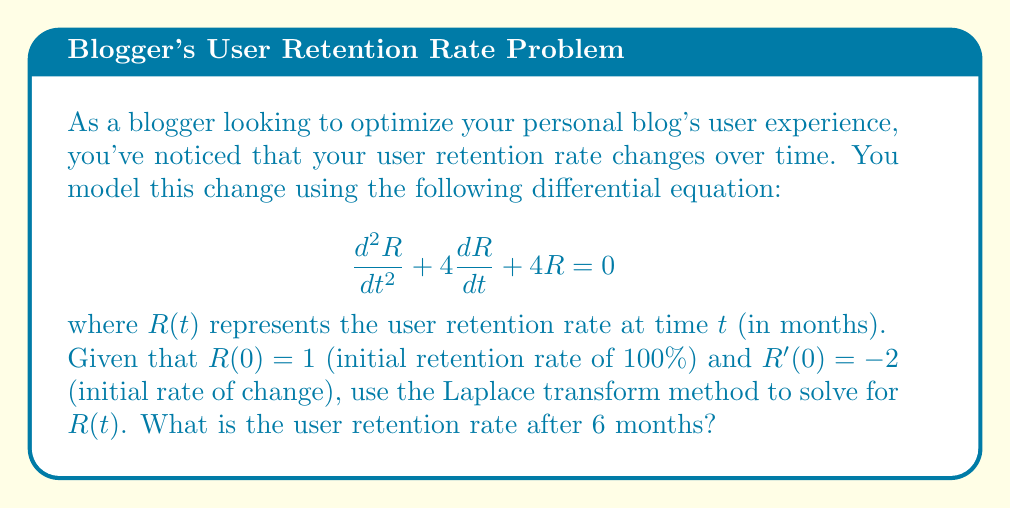Could you help me with this problem? Let's solve this step-by-step using the Laplace transform method:

1) Take the Laplace transform of both sides of the equation:
   $$\mathcal{L}\{R''(t)\} + 4\mathcal{L}\{R'(t)\} + 4\mathcal{L}\{R(t)\} = 0$$

2) Using Laplace transform properties:
   $$[s^2\mathcal{L}\{R(t)\} - sR(0) - R'(0)] + 4[s\mathcal{L}\{R(t)\} - R(0)] + 4\mathcal{L}\{R(t)\} = 0$$

3) Let $\mathcal{L}\{R(t)\} = X(s)$. Substitute the initial conditions:
   $$s^2X(s) - s - (-2) + 4sX(s) - 4 + 4X(s) = 0$$

4) Simplify:
   $$s^2X(s) + 4sX(s) + 4X(s) = s + 2 + 4$$
   $$(s^2 + 4s + 4)X(s) = s + 6$$

5) Solve for $X(s)$:
   $$X(s) = \frac{s + 6}{s^2 + 4s + 4} = \frac{s + 6}{(s + 2)^2}$$

6) Decompose into partial fractions:
   $$X(s) = \frac{A}{s + 2} + \frac{B}{(s + 2)^2}$$
   
   Solving for A and B, we get $A = 1$ and $B = 2$

7) Rewrite $X(s)$:
   $$X(s) = \frac{1}{s + 2} + \frac{2}{(s + 2)^2}$$

8) Take the inverse Laplace transform:
   $$R(t) = e^{-2t} + 2te^{-2t}$$

9) To find the retention rate after 6 months, substitute $t = 6$:
   $$R(6) = e^{-12} + 12e^{-12} \approx 0.0022$$
Answer: $R(6) \approx 0.0022$ or 0.22% 